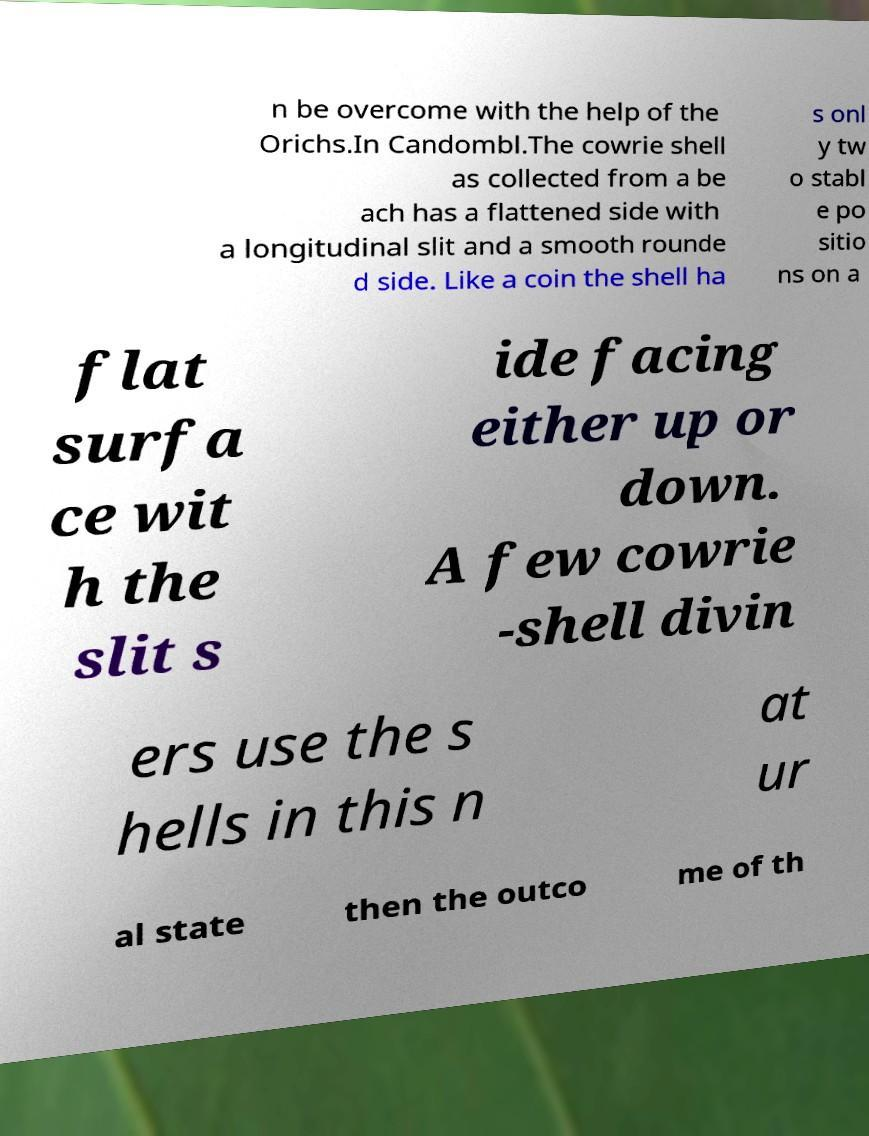There's text embedded in this image that I need extracted. Can you transcribe it verbatim? n be overcome with the help of the Orichs.In Candombl.The cowrie shell as collected from a be ach has a flattened side with a longitudinal slit and a smooth rounde d side. Like a coin the shell ha s onl y tw o stabl e po sitio ns on a flat surfa ce wit h the slit s ide facing either up or down. A few cowrie -shell divin ers use the s hells in this n at ur al state then the outco me of th 